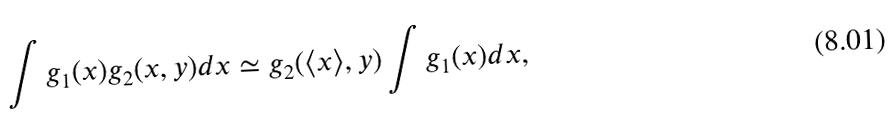<formula> <loc_0><loc_0><loc_500><loc_500>\int g _ { 1 } ( x ) g _ { 2 } ( x , y ) d x \simeq g _ { 2 } ( \langle x \rangle , y ) \int g _ { 1 } ( x ) d x ,</formula> 